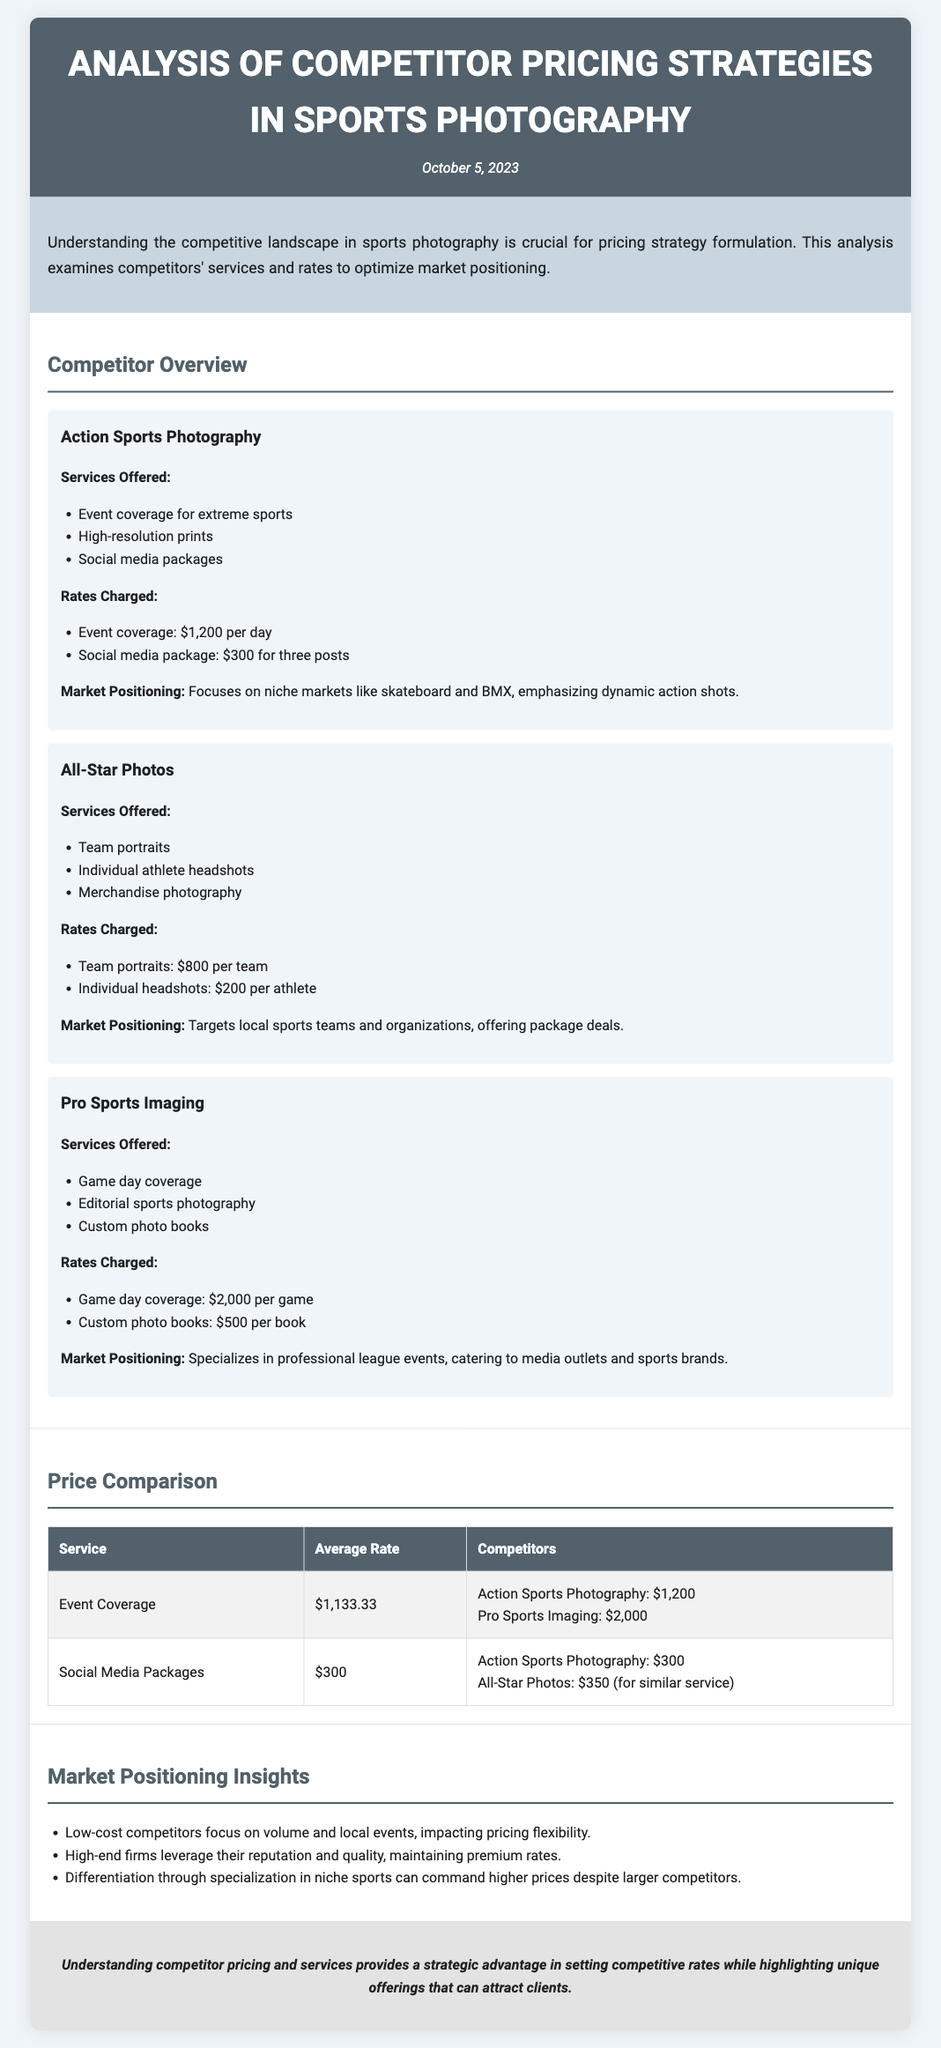what services does Action Sports Photography offer? Action Sports Photography offers event coverage for extreme sports, high-resolution prints, and social media packages.
Answer: event coverage for extreme sports, high-resolution prints, social media packages what is the rate charged for team portraits by All-Star Photos? All-Star Photos charges $800 per team for team portraits.
Answer: $800 per team what is the average rate for social media packages across competitors? The average rate for social media packages is calculated as the mean of the competitors' rates, which is $300.
Answer: $300 what is the market positioning of Pro Sports Imaging? Pro Sports Imaging specializes in professional league events, catering to media outlets and sports brands.
Answer: specializes in professional league events which competitor charges the highest for event coverage? Pro Sports Imaging charges $2,000 per game, which is the highest among competitors for event coverage.
Answer: Pro Sports Imaging how do low-cost competitors affect pricing flexibility? Low-cost competitors focus on volume and local events, which impacts pricing flexibility for others.
Answer: impacts pricing flexibility what is the publication date of the document? The document mentions the publication date in the header section.
Answer: October 5, 2023 what conclusion is drawn about understanding competitor pricing? The conclusion states that understanding competitor pricing provides a strategic advantage in setting competitive rates.
Answer: strategic advantage in setting competitive rates 